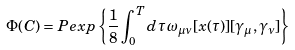Convert formula to latex. <formula><loc_0><loc_0><loc_500><loc_500>\Phi ( C ) = P e x p \left \{ \frac { 1 } { 8 } \int _ { 0 } ^ { T } d \tau \, \omega _ { \mu \nu } [ x ( \tau ) ] [ \gamma _ { \mu } , \gamma _ { \nu } ] \right \}</formula> 